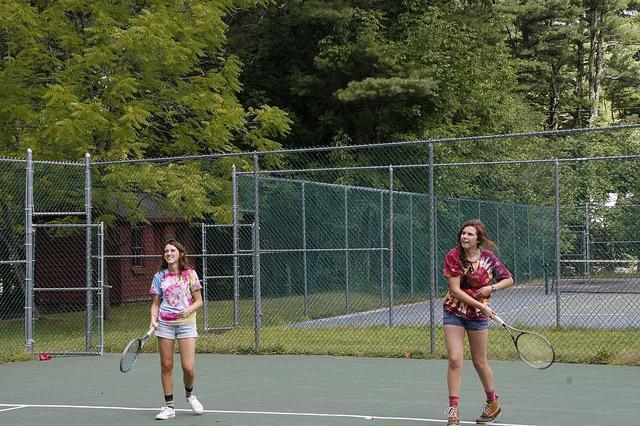How many people are smoking?
Give a very brief answer. 0. How many children are in the picture?
Give a very brief answer. 2. How many people are there?
Give a very brief answer. 2. 